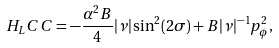<formula> <loc_0><loc_0><loc_500><loc_500>H _ { L } C C = - \frac { \alpha ^ { 2 } B } { 4 } | \nu | \sin ^ { 2 } ( 2 \sigma ) + B | \nu | ^ { - 1 } p _ { \phi } ^ { 2 } ,</formula> 